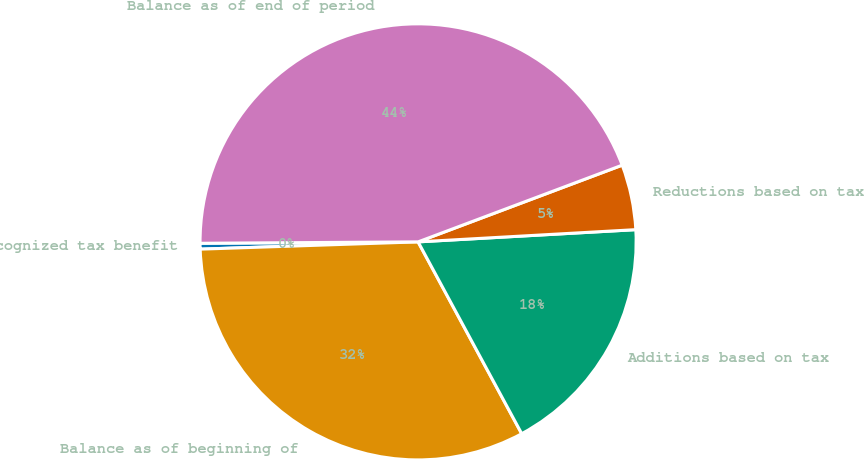Convert chart. <chart><loc_0><loc_0><loc_500><loc_500><pie_chart><fcel>Unrecognized tax benefit<fcel>Balance as of beginning of<fcel>Additions based on tax<fcel>Reductions based on tax<fcel>Balance as of end of period<nl><fcel>0.43%<fcel>32.35%<fcel>18.01%<fcel>4.83%<fcel>44.38%<nl></chart> 